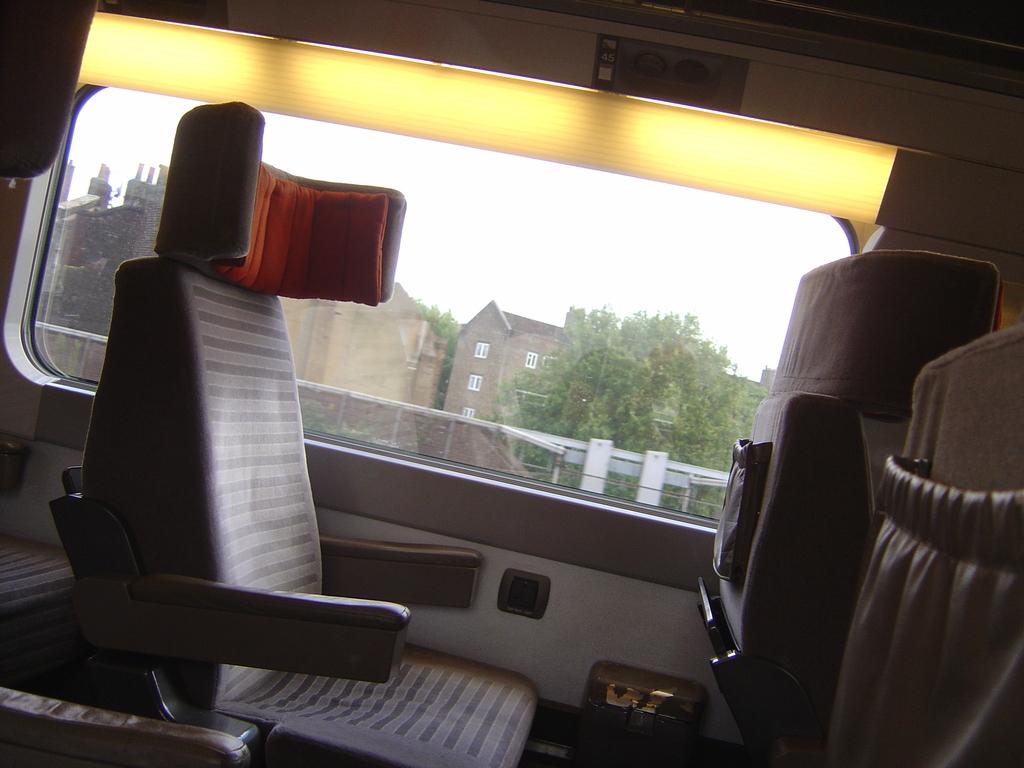What is the main subject of the image? There is a vehicle in the image. What can be found inside the vehicle? The vehicle has seats. What is located at the front of the vehicle? There is a window in the front of the vehicle. What can be seen through the window? Buildings and trees are visible through the window. How many heads of the dog can be seen in the image? There is no dog present in the image, so it is not possible to determine the number of heads. What type of can is visible in the image? There is no can present in the image. 